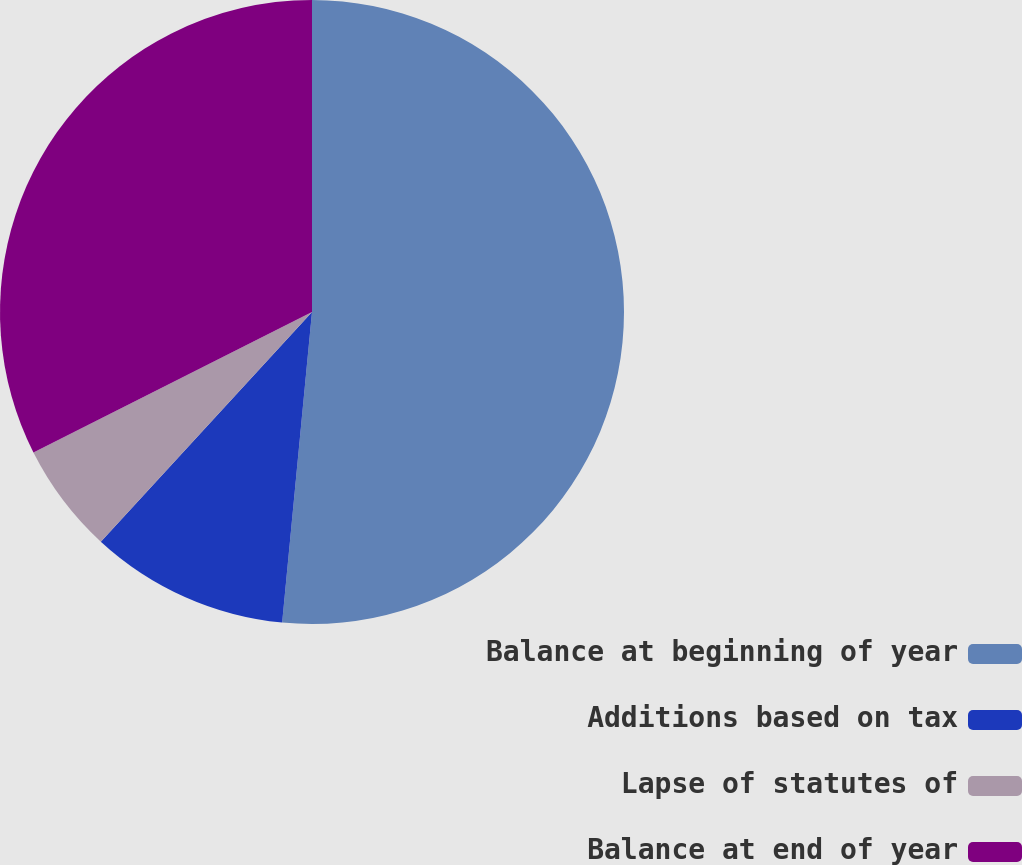Convert chart. <chart><loc_0><loc_0><loc_500><loc_500><pie_chart><fcel>Balance at beginning of year<fcel>Additions based on tax<fcel>Lapse of statutes of<fcel>Balance at end of year<nl><fcel>51.53%<fcel>10.31%<fcel>5.73%<fcel>32.44%<nl></chart> 